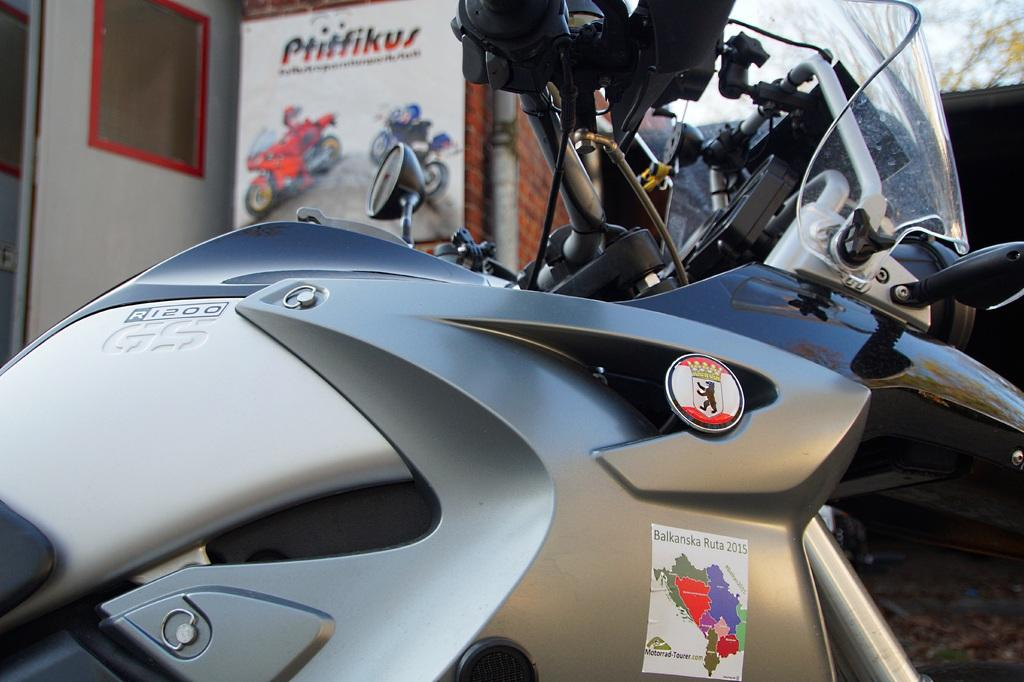What is the main object in the image? There is a bike in the image. Can you describe anything in the background of the image? There is a board visible in the background of the image. What degree is the bike leaning in the image? The bike's leaning angle cannot be determined from the image, as it appears to be standing upright. How many children are riding the bike in the image? There are no children present in the image; it only features a bike. 